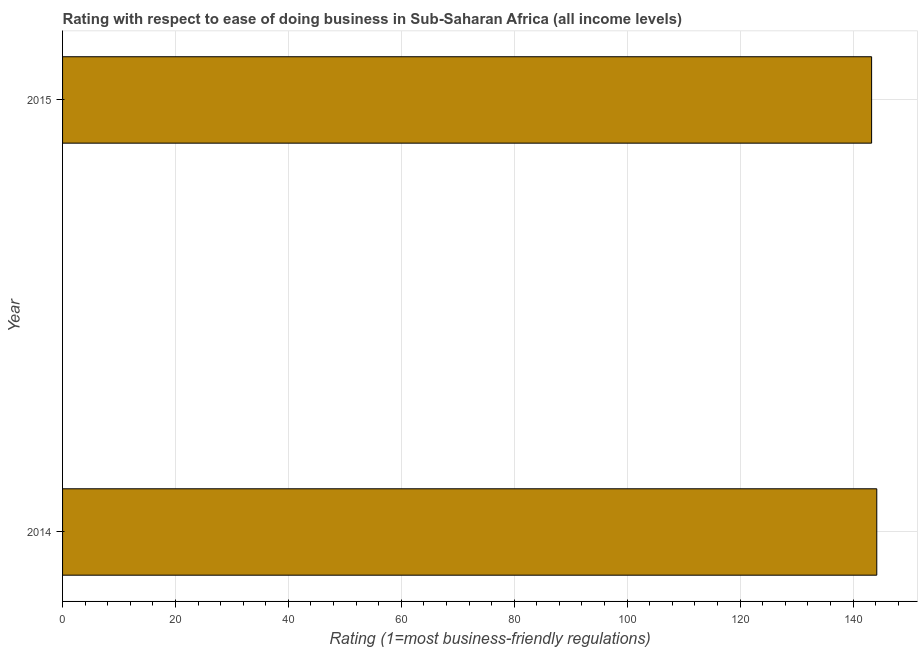Does the graph contain any zero values?
Offer a very short reply. No. Does the graph contain grids?
Your answer should be compact. Yes. What is the title of the graph?
Ensure brevity in your answer.  Rating with respect to ease of doing business in Sub-Saharan Africa (all income levels). What is the label or title of the X-axis?
Provide a short and direct response. Rating (1=most business-friendly regulations). What is the label or title of the Y-axis?
Your answer should be compact. Year. What is the ease of doing business index in 2015?
Ensure brevity in your answer.  143.3. Across all years, what is the maximum ease of doing business index?
Keep it short and to the point. 144.21. Across all years, what is the minimum ease of doing business index?
Your answer should be compact. 143.3. In which year was the ease of doing business index maximum?
Provide a short and direct response. 2014. In which year was the ease of doing business index minimum?
Make the answer very short. 2015. What is the sum of the ease of doing business index?
Your response must be concise. 287.51. What is the difference between the ease of doing business index in 2014 and 2015?
Your answer should be compact. 0.92. What is the average ease of doing business index per year?
Offer a terse response. 143.75. What is the median ease of doing business index?
Provide a short and direct response. 143.76. Do a majority of the years between 2015 and 2014 (inclusive) have ease of doing business index greater than 52 ?
Provide a short and direct response. No. Is the ease of doing business index in 2014 less than that in 2015?
Provide a short and direct response. No. In how many years, is the ease of doing business index greater than the average ease of doing business index taken over all years?
Offer a very short reply. 1. How many bars are there?
Your response must be concise. 2. How many years are there in the graph?
Your answer should be compact. 2. What is the difference between two consecutive major ticks on the X-axis?
Offer a terse response. 20. What is the Rating (1=most business-friendly regulations) in 2014?
Provide a short and direct response. 144.21. What is the Rating (1=most business-friendly regulations) of 2015?
Make the answer very short. 143.3. What is the difference between the Rating (1=most business-friendly regulations) in 2014 and 2015?
Ensure brevity in your answer.  0.91. What is the ratio of the Rating (1=most business-friendly regulations) in 2014 to that in 2015?
Your answer should be very brief. 1.01. 